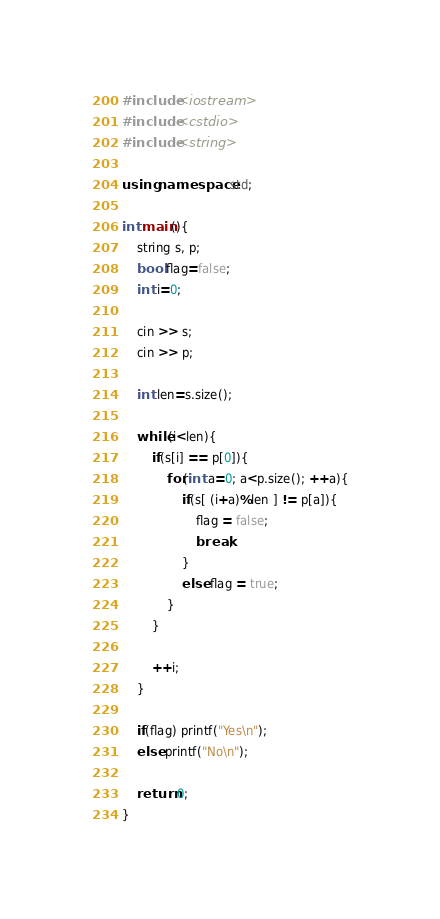<code> <loc_0><loc_0><loc_500><loc_500><_C++_>#include <iostream>
#include <cstdio>
#include <string>

using namespace std;

int main(){
	string s, p;
	bool flag=false;
	int i=0;
	
	cin >> s;
	cin >> p;
	
	int len=s.size();
	
	while(i<len){
		if(s[i] == p[0]){
			for(int a=0; a<p.size(); ++a){
				if(s[ (i+a)%len ] != p[a]){
					flag = false; 
					break;
				}
				else flag = true;
			}
		}
	
		++i;
	}
	
	if(flag) printf("Yes\n");
	else printf("No\n");

	return 0;
}</code> 